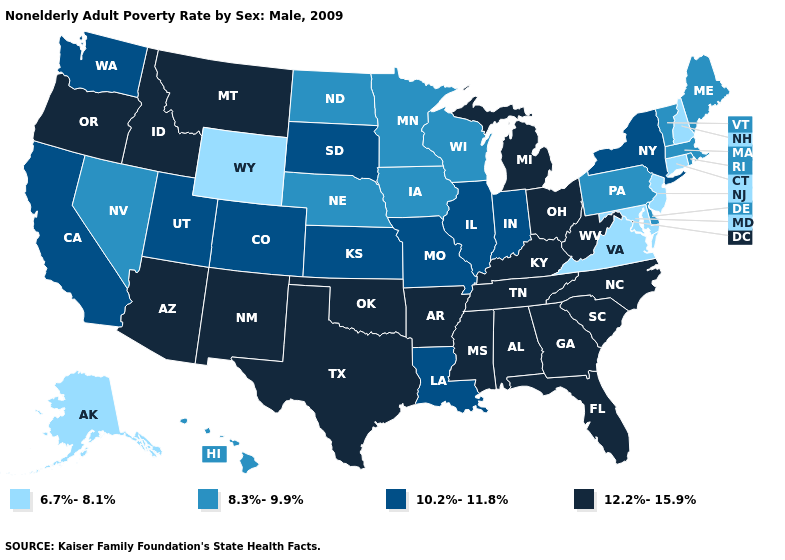Among the states that border Montana , which have the lowest value?
Keep it brief. Wyoming. Name the states that have a value in the range 8.3%-9.9%?
Be succinct. Delaware, Hawaii, Iowa, Maine, Massachusetts, Minnesota, Nebraska, Nevada, North Dakota, Pennsylvania, Rhode Island, Vermont, Wisconsin. Does Michigan have the highest value in the MidWest?
Quick response, please. Yes. Name the states that have a value in the range 6.7%-8.1%?
Quick response, please. Alaska, Connecticut, Maryland, New Hampshire, New Jersey, Virginia, Wyoming. What is the value of Tennessee?
Answer briefly. 12.2%-15.9%. Name the states that have a value in the range 6.7%-8.1%?
Be succinct. Alaska, Connecticut, Maryland, New Hampshire, New Jersey, Virginia, Wyoming. What is the value of Louisiana?
Answer briefly. 10.2%-11.8%. What is the value of Nevada?
Quick response, please. 8.3%-9.9%. What is the value of Ohio?
Answer briefly. 12.2%-15.9%. What is the value of Kansas?
Keep it brief. 10.2%-11.8%. Which states hav the highest value in the MidWest?
Answer briefly. Michigan, Ohio. What is the value of Minnesota?
Concise answer only. 8.3%-9.9%. Among the states that border Kentucky , does Ohio have the highest value?
Keep it brief. Yes. What is the lowest value in the USA?
Give a very brief answer. 6.7%-8.1%. Name the states that have a value in the range 8.3%-9.9%?
Quick response, please. Delaware, Hawaii, Iowa, Maine, Massachusetts, Minnesota, Nebraska, Nevada, North Dakota, Pennsylvania, Rhode Island, Vermont, Wisconsin. 